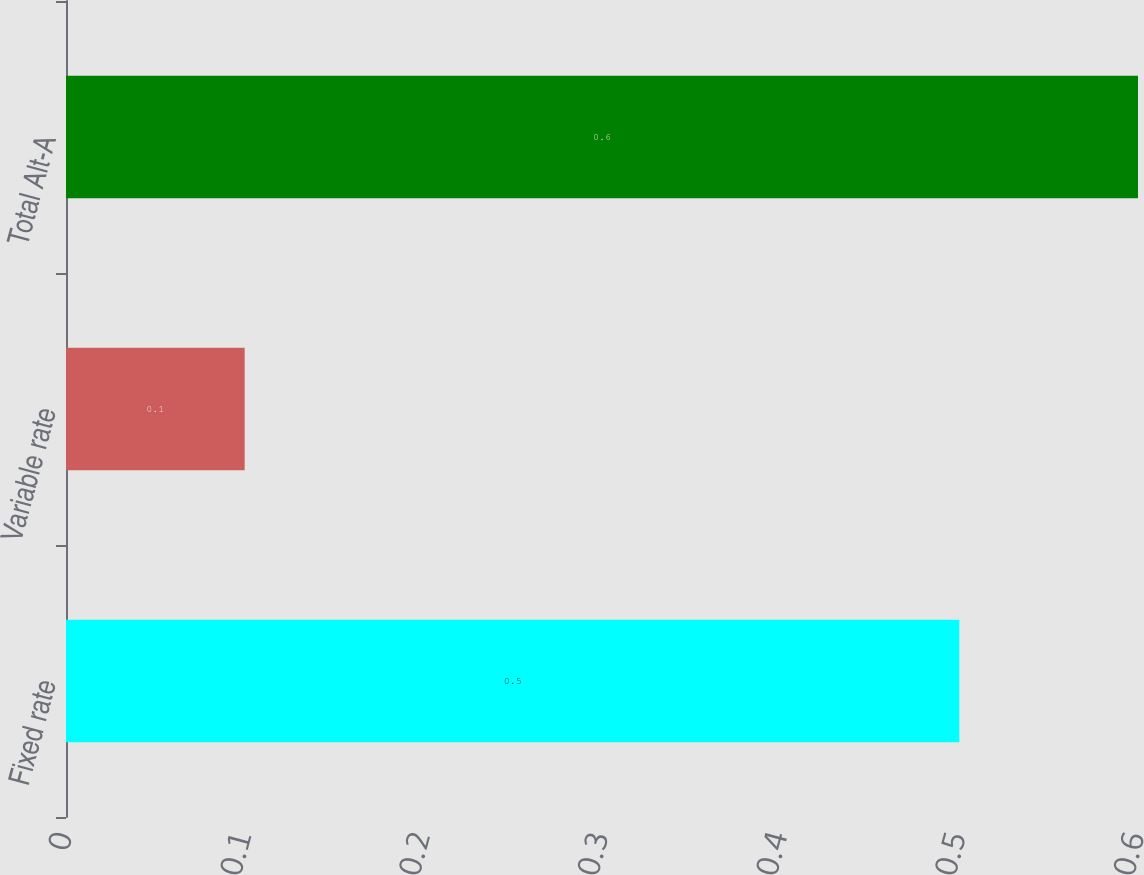Convert chart. <chart><loc_0><loc_0><loc_500><loc_500><bar_chart><fcel>Fixed rate<fcel>Variable rate<fcel>Total Alt-A<nl><fcel>0.5<fcel>0.1<fcel>0.6<nl></chart> 